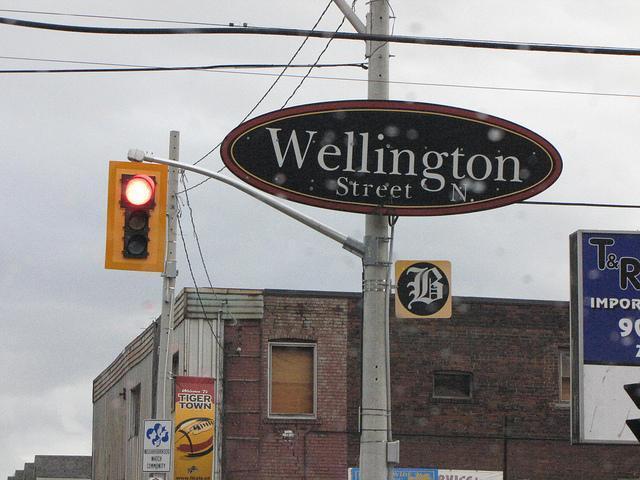How many signs are there?
Give a very brief answer. 5. 